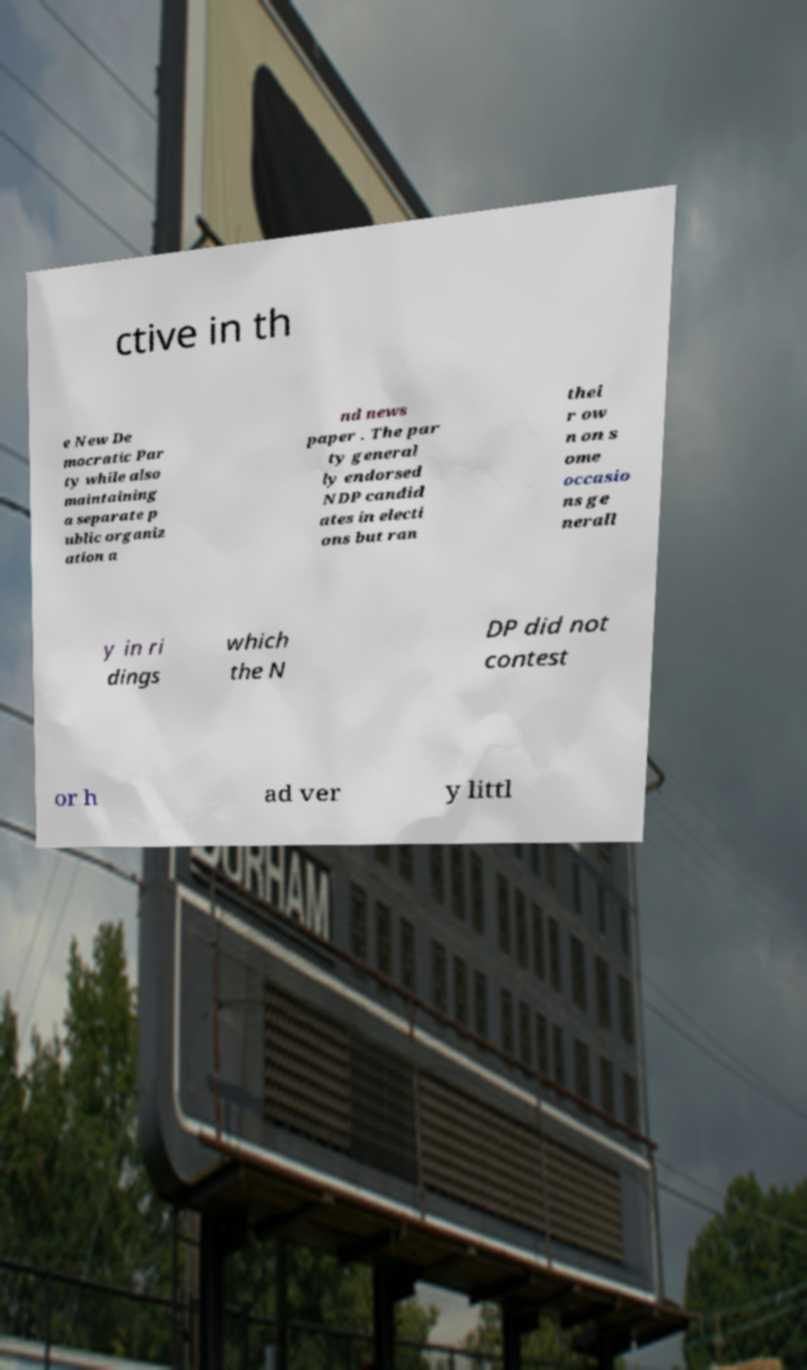Can you read and provide the text displayed in the image?This photo seems to have some interesting text. Can you extract and type it out for me? ctive in th e New De mocratic Par ty while also maintaining a separate p ublic organiz ation a nd news paper . The par ty general ly endorsed NDP candid ates in electi ons but ran thei r ow n on s ome occasio ns ge nerall y in ri dings which the N DP did not contest or h ad ver y littl 